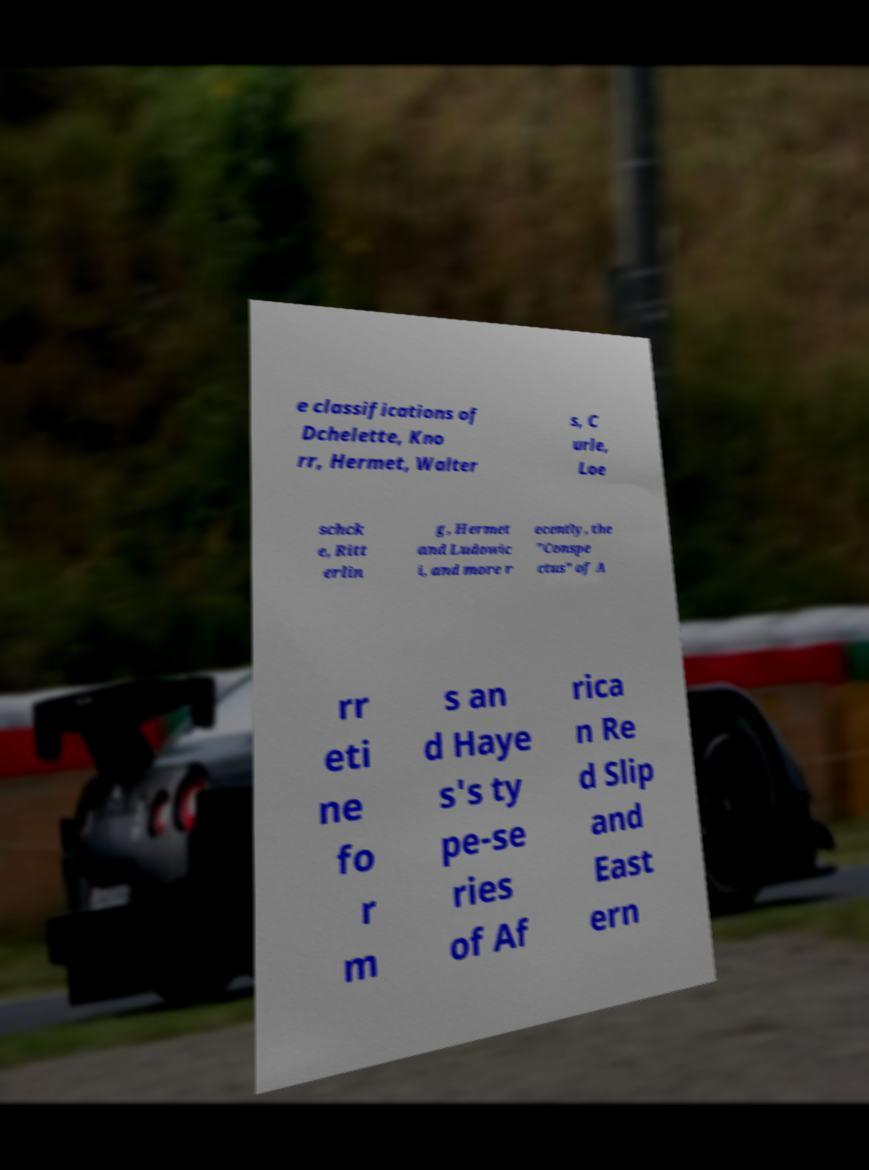Could you extract and type out the text from this image? e classifications of Dchelette, Kno rr, Hermet, Walter s, C urle, Loe schck e, Ritt erlin g, Hermet and Ludowic i, and more r ecently, the "Conspe ctus" of A rr eti ne fo r m s an d Haye s's ty pe-se ries of Af rica n Re d Slip and East ern 